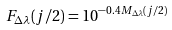<formula> <loc_0><loc_0><loc_500><loc_500>F _ { \Delta \lambda } ( j / 2 ) = 1 0 ^ { - 0 . 4 M _ { \Delta \lambda } ( j / 2 ) }</formula> 